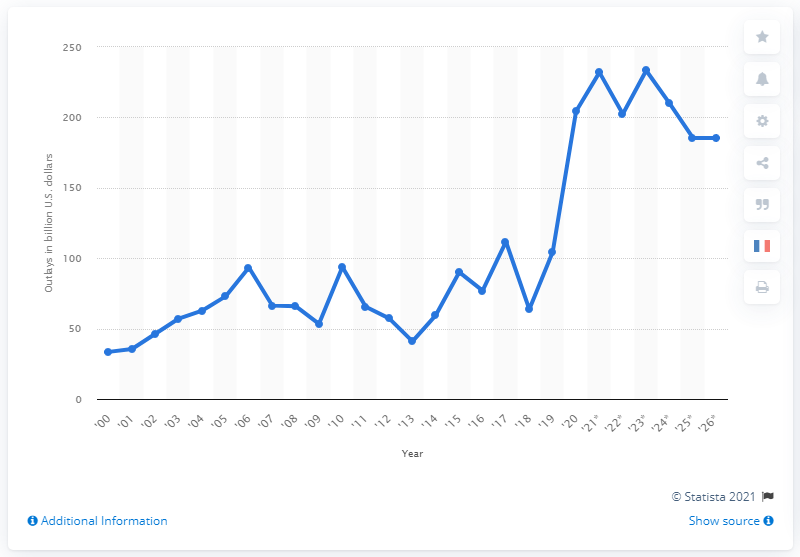Draw attention to some important aspects in this diagram. By 2026, it is expected that the Department of Education will spend a total of 185.39... In 2020, the Department of Education spent approximately 202.4 million dollars. 